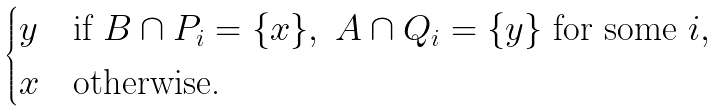Convert formula to latex. <formula><loc_0><loc_0><loc_500><loc_500>\begin{cases} y & \text {if } B \cap P _ { i } = \{ x \} , \ A \cap Q _ { i } = \{ y \} \text { for some } i , \\ x & \text {otherwise.} \end{cases}</formula> 